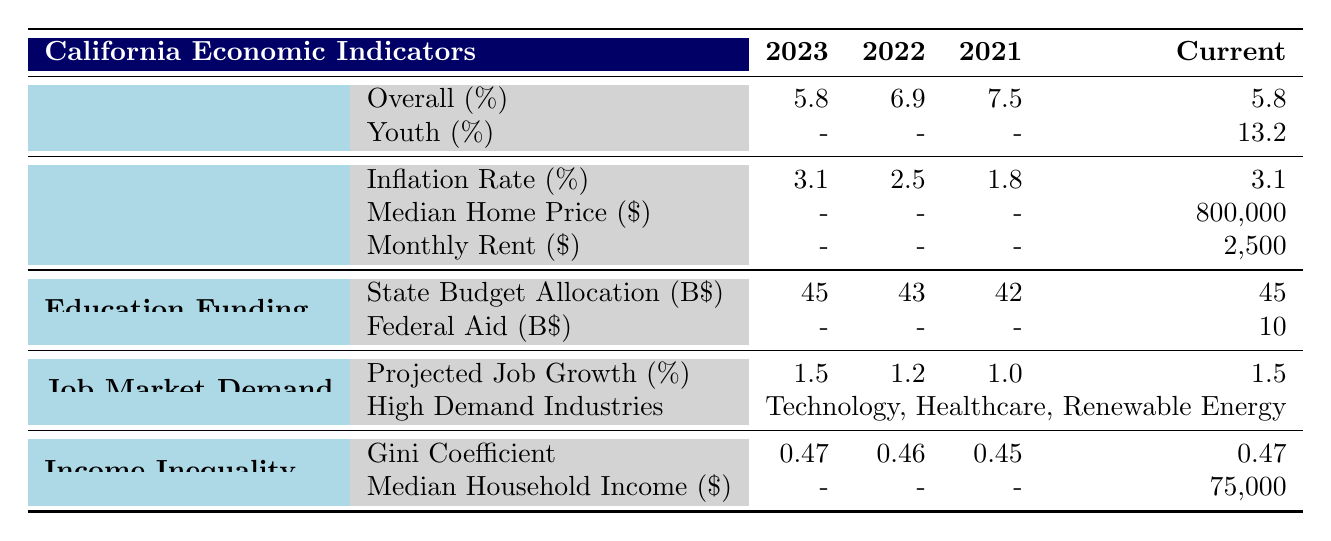What is the current overall unemployment rate in California? The table indicates the overall unemployment rate for the current year is listed under the "Unemployment Rate" category, which shows a value of 5.8% for 2023.
Answer: 5.8% What was the projected job growth percentage for 2023? The "Projected Job Growth" under the "Job Market Demand" category states that the percentage for 2023 is 1.5%.
Answer: 1.5% Is the youth unemployment rate data available in the table? The table shows that the youth unemployment rate for the current year is provided, showing a figure of 13.2%.
Answer: Yes What is the percentage increase in state budget allocation from 2021 to 2023? The state budget allocation in 2021 was 42 billion and in 2023 it is 45 billion. The increase can be calculated as (45 - 42) = 3 billion. To find the percentage increase, we calculate (3/42) * 100, which is approximately 7.14%.
Answer: 7.14% What was the median household income in California in 2023? Looking at the "Income Inequality" category, the median household income for 2023 is directly provided, which is 75,000 dollars.
Answer: 75,000 How much did the inflation rate increase from 2021 to 2023? The inflation rates for 2021, 2022, and 2023 are 1.8%, 2.5%, and 3.1%, respectively. The increase from 2021 to 2023 can be calculated as (3.1 - 1.8) = 1.3 percentage points.
Answer: 1.3 What percentage of the state budget is allocated to education funding in 2023? According to the "Education Funding" category, the state budget allocation for education in 2023 is 45 billion. This value directly answers the question regarding budget allocation for that year.
Answer: 45 billion Did the Gini coefficient increase from 2021 to 2023? The Gini coefficients for 2021, 2022, and 2023 are 0.45, 0.46, and 0.47, respectively. This shows that the coefficient has increased over the two-year period from 0.45 to 0.47, indicating a true statement.
Answer: Yes What are the high-demand industries projected for job growth in California? The table lists "Technology," "Healthcare," and "Renewable Energy" under the "High Demand Industries" section in the "Job Market Demand" category. This information identifies the sectors expected to have job growth.
Answer: Technology, Healthcare, Renewable Energy 